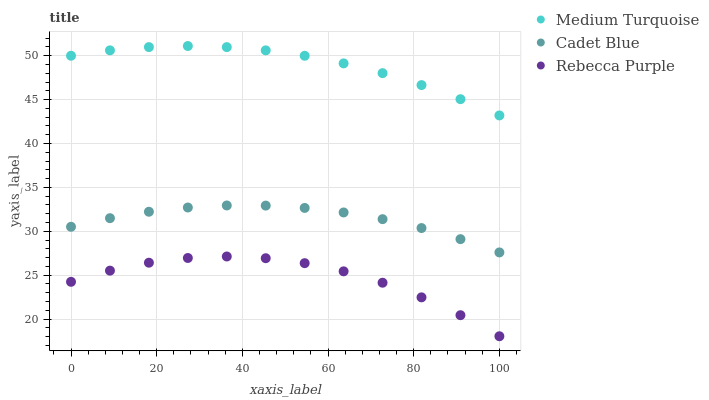Does Rebecca Purple have the minimum area under the curve?
Answer yes or no. Yes. Does Medium Turquoise have the maximum area under the curve?
Answer yes or no. Yes. Does Medium Turquoise have the minimum area under the curve?
Answer yes or no. No. Does Rebecca Purple have the maximum area under the curve?
Answer yes or no. No. Is Medium Turquoise the smoothest?
Answer yes or no. Yes. Is Rebecca Purple the roughest?
Answer yes or no. Yes. Is Rebecca Purple the smoothest?
Answer yes or no. No. Is Medium Turquoise the roughest?
Answer yes or no. No. Does Rebecca Purple have the lowest value?
Answer yes or no. Yes. Does Medium Turquoise have the lowest value?
Answer yes or no. No. Does Medium Turquoise have the highest value?
Answer yes or no. Yes. Does Rebecca Purple have the highest value?
Answer yes or no. No. Is Cadet Blue less than Medium Turquoise?
Answer yes or no. Yes. Is Medium Turquoise greater than Cadet Blue?
Answer yes or no. Yes. Does Cadet Blue intersect Medium Turquoise?
Answer yes or no. No. 